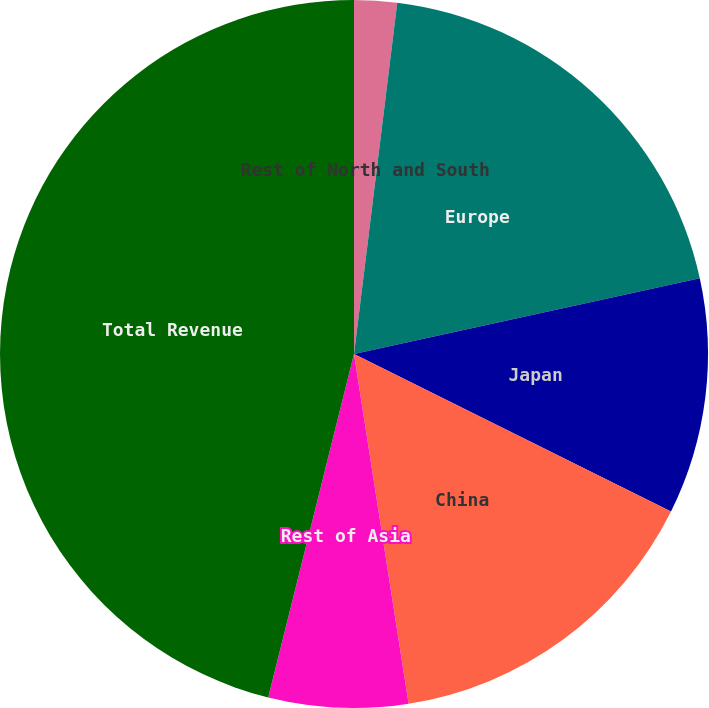Convert chart to OTSL. <chart><loc_0><loc_0><loc_500><loc_500><pie_chart><fcel>Rest of North and South<fcel>Europe<fcel>Japan<fcel>China<fcel>Rest of Asia<fcel>Total Revenue<nl><fcel>1.95%<fcel>19.61%<fcel>10.78%<fcel>15.19%<fcel>6.36%<fcel>46.1%<nl></chart> 